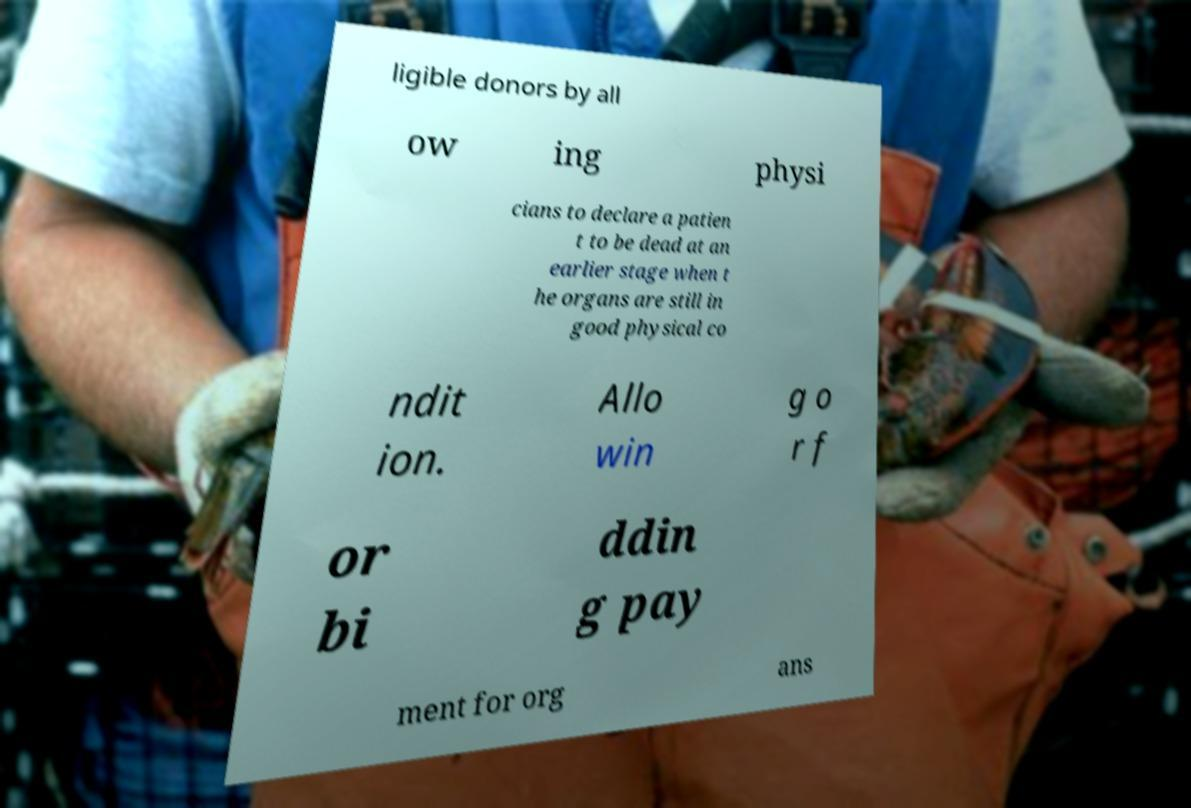Can you accurately transcribe the text from the provided image for me? ligible donors by all ow ing physi cians to declare a patien t to be dead at an earlier stage when t he organs are still in good physical co ndit ion. Allo win g o r f or bi ddin g pay ment for org ans 